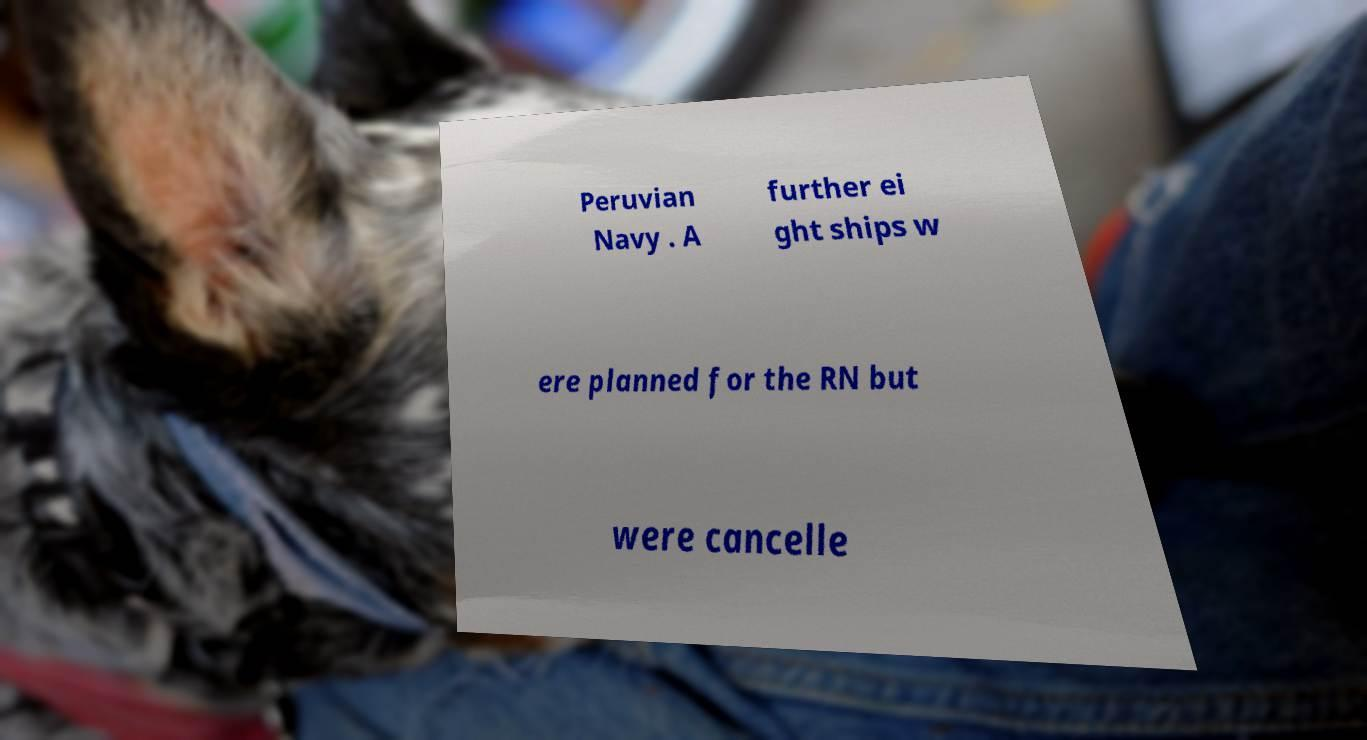Can you read and provide the text displayed in the image?This photo seems to have some interesting text. Can you extract and type it out for me? Peruvian Navy . A further ei ght ships w ere planned for the RN but were cancelle 